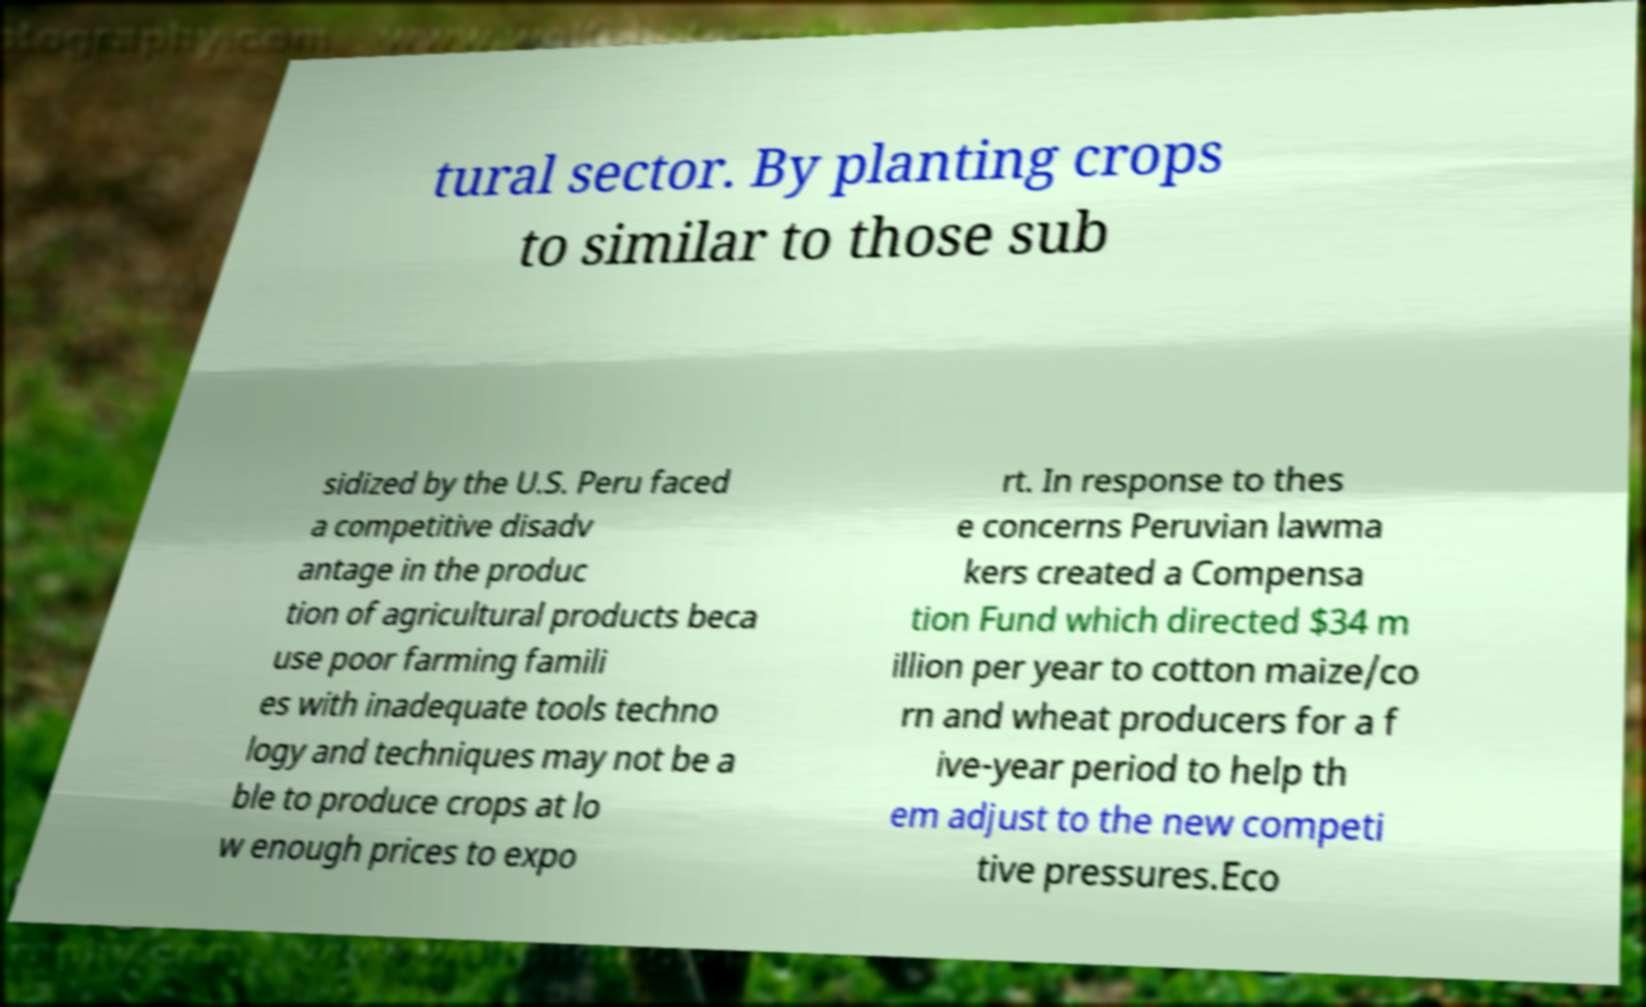Can you read and provide the text displayed in the image?This photo seems to have some interesting text. Can you extract and type it out for me? tural sector. By planting crops to similar to those sub sidized by the U.S. Peru faced a competitive disadv antage in the produc tion of agricultural products beca use poor farming famili es with inadequate tools techno logy and techniques may not be a ble to produce crops at lo w enough prices to expo rt. In response to thes e concerns Peruvian lawma kers created a Compensa tion Fund which directed $34 m illion per year to cotton maize/co rn and wheat producers for a f ive-year period to help th em adjust to the new competi tive pressures.Eco 